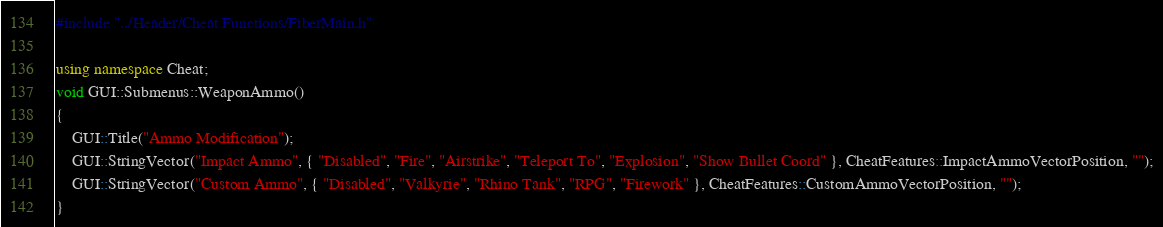Convert code to text. <code><loc_0><loc_0><loc_500><loc_500><_C++_>#include "../Header/Cheat Functions/FiberMain.h"

using namespace Cheat;
void GUI::Submenus::WeaponAmmo()
{
	GUI::Title("Ammo Modification");
	GUI::StringVector("Impact Ammo", { "Disabled", "Fire", "Airstrike", "Teleport To", "Explosion", "Show Bullet Coord" }, CheatFeatures::ImpactAmmoVectorPosition, "");
	GUI::StringVector("Custom Ammo", { "Disabled", "Valkyrie", "Rhino Tank", "RPG", "Firework" }, CheatFeatures::CustomAmmoVectorPosition, "");
}</code> 